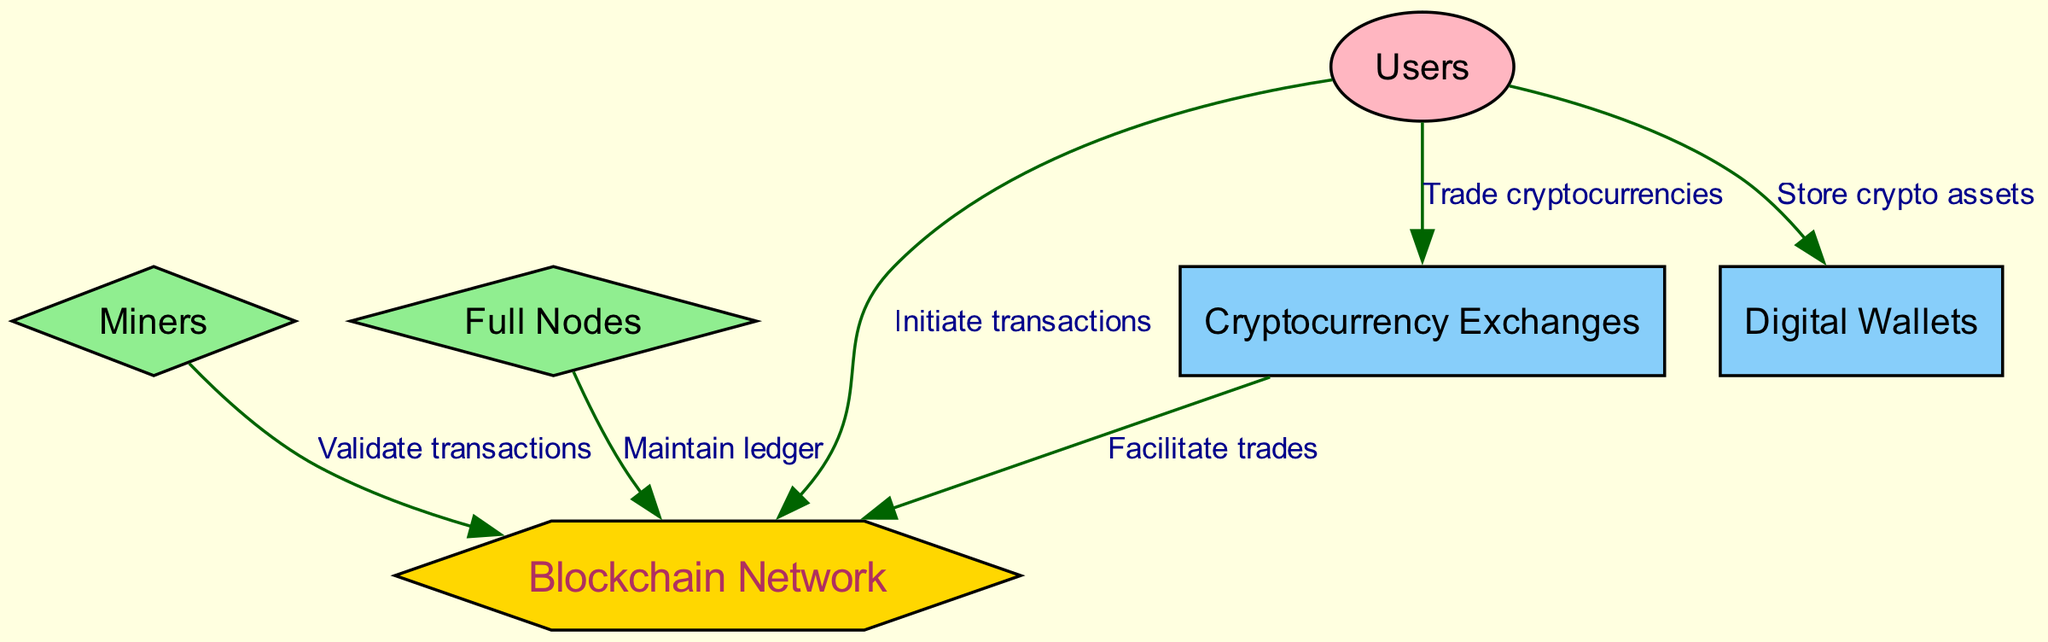What is the central component of the diagram? The diagram shows various components of a blockchain ecosystem with the Blockchain Network at the center, which is represented as a hexagon.
Answer: Blockchain Network How many nodes are present in the diagram? The diagram included six distinct nodes: Blockchain Network, Miners, Full Nodes, Users, Cryptocurrency Exchanges, and Digital Wallets. Counting these nodes gives a total of six.
Answer: 6 What role do miners play in the blockchain ecosystem? According to the diagram, miners validate transactions, which is indicated by the edge label connecting miners to the blockchain.
Answer: Validate transactions Which nodes are connected to the users? The diagram indicates that Users connect to Cryptocurrency Exchanges and Digital Wallets, as shown by the edges leading from the Users node to these two nodes.
Answer: Cryptocurrency Exchanges, Digital Wallets What do full nodes maintain? The diagram states that Full Nodes maintain the ledger, which is represented by the edge label connecting Full Nodes to the Blockchain Network.
Answer: Ledger How do exchanges interact with the blockchain? Exchanges facilitate trades, which is detailed in the diagram through the edge pointing from Exchanges to the Blockchain Network indicating this relationship.
Answer: Facilitate trades Which node initiates transactions in this ecosystem? The diagram specifies that it is the Users who initiate transactions, as represented by the directed edge from the Users node to the Blockchain Network.
Answer: Users Why are miners considered crucial to the blockchain? In the diagram, miners are depicted as validating transactions, which is essential for maintaining the integrity and security of the entire blockchain ecosystem. This function highlights why miners are essential.
Answer: Validating transactions What shape represents the Blockchain Network? The unique representation of the Blockchain Network in the diagram is a hexagon, which differentiates it from other nodes that use different shapes.
Answer: Hexagon 